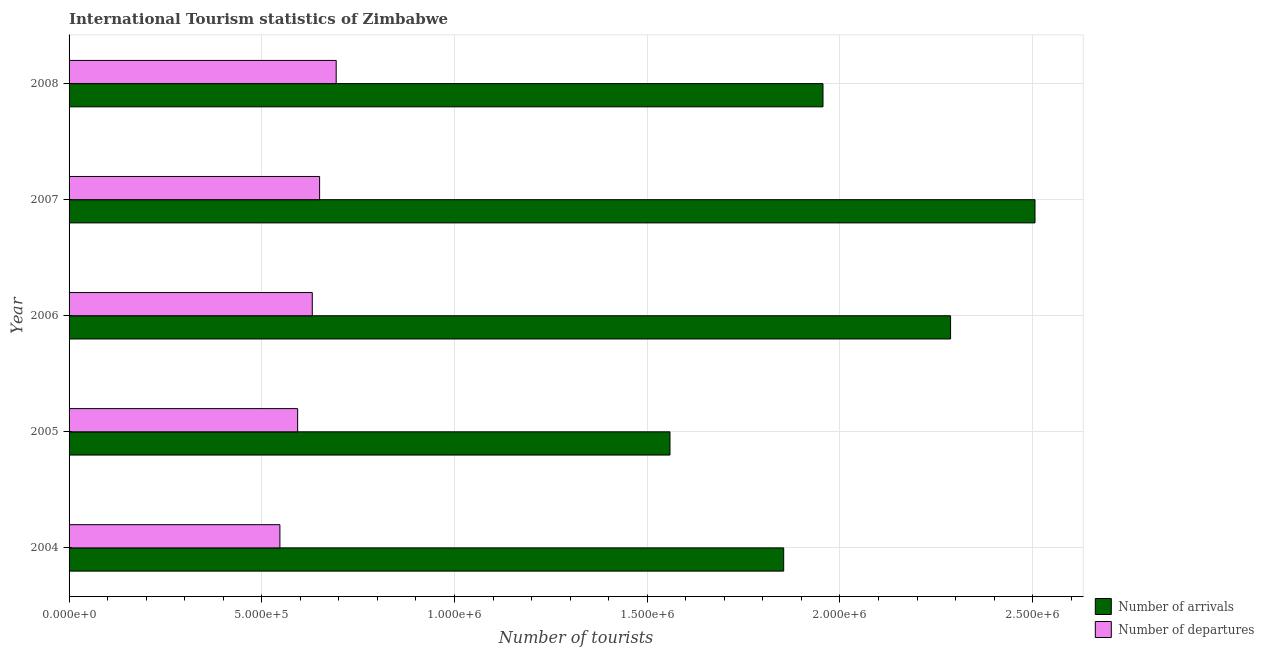Are the number of bars per tick equal to the number of legend labels?
Make the answer very short. Yes. How many bars are there on the 3rd tick from the top?
Provide a short and direct response. 2. How many bars are there on the 1st tick from the bottom?
Offer a terse response. 2. What is the label of the 4th group of bars from the top?
Ensure brevity in your answer.  2005. What is the number of tourist departures in 2005?
Your answer should be very brief. 5.93e+05. Across all years, what is the maximum number of tourist arrivals?
Offer a very short reply. 2.51e+06. Across all years, what is the minimum number of tourist arrivals?
Keep it short and to the point. 1.56e+06. In which year was the number of tourist departures maximum?
Your response must be concise. 2008. What is the total number of tourist departures in the graph?
Make the answer very short. 3.11e+06. What is the difference between the number of tourist arrivals in 2007 and that in 2008?
Provide a succinct answer. 5.50e+05. What is the difference between the number of tourist departures in 2004 and the number of tourist arrivals in 2005?
Make the answer very short. -1.01e+06. What is the average number of tourist arrivals per year?
Provide a short and direct response. 2.03e+06. In the year 2008, what is the difference between the number of tourist departures and number of tourist arrivals?
Provide a succinct answer. -1.26e+06. In how many years, is the number of tourist departures greater than 600000 ?
Provide a short and direct response. 3. What is the ratio of the number of tourist arrivals in 2005 to that in 2006?
Make the answer very short. 0.68. Is the difference between the number of tourist departures in 2007 and 2008 greater than the difference between the number of tourist arrivals in 2007 and 2008?
Give a very brief answer. No. What is the difference between the highest and the second highest number of tourist departures?
Ensure brevity in your answer.  4.30e+04. What is the difference between the highest and the lowest number of tourist arrivals?
Your response must be concise. 9.47e+05. In how many years, is the number of tourist departures greater than the average number of tourist departures taken over all years?
Your answer should be compact. 3. Is the sum of the number of tourist arrivals in 2004 and 2007 greater than the maximum number of tourist departures across all years?
Offer a terse response. Yes. What does the 1st bar from the top in 2005 represents?
Your response must be concise. Number of departures. What does the 2nd bar from the bottom in 2006 represents?
Provide a short and direct response. Number of departures. How many bars are there?
Your response must be concise. 10. What is the difference between two consecutive major ticks on the X-axis?
Your answer should be very brief. 5.00e+05. Are the values on the major ticks of X-axis written in scientific E-notation?
Your answer should be compact. Yes. Where does the legend appear in the graph?
Offer a very short reply. Bottom right. How many legend labels are there?
Keep it short and to the point. 2. How are the legend labels stacked?
Provide a succinct answer. Vertical. What is the title of the graph?
Give a very brief answer. International Tourism statistics of Zimbabwe. What is the label or title of the X-axis?
Your answer should be very brief. Number of tourists. What is the Number of tourists of Number of arrivals in 2004?
Provide a succinct answer. 1.85e+06. What is the Number of tourists of Number of departures in 2004?
Your answer should be compact. 5.47e+05. What is the Number of tourists in Number of arrivals in 2005?
Give a very brief answer. 1.56e+06. What is the Number of tourists in Number of departures in 2005?
Ensure brevity in your answer.  5.93e+05. What is the Number of tourists of Number of arrivals in 2006?
Ensure brevity in your answer.  2.29e+06. What is the Number of tourists of Number of departures in 2006?
Your response must be concise. 6.31e+05. What is the Number of tourists of Number of arrivals in 2007?
Provide a short and direct response. 2.51e+06. What is the Number of tourists in Number of departures in 2007?
Ensure brevity in your answer.  6.50e+05. What is the Number of tourists in Number of arrivals in 2008?
Keep it short and to the point. 1.96e+06. What is the Number of tourists of Number of departures in 2008?
Your answer should be compact. 6.93e+05. Across all years, what is the maximum Number of tourists in Number of arrivals?
Keep it short and to the point. 2.51e+06. Across all years, what is the maximum Number of tourists in Number of departures?
Give a very brief answer. 6.93e+05. Across all years, what is the minimum Number of tourists in Number of arrivals?
Give a very brief answer. 1.56e+06. Across all years, what is the minimum Number of tourists in Number of departures?
Give a very brief answer. 5.47e+05. What is the total Number of tourists in Number of arrivals in the graph?
Your answer should be compact. 1.02e+07. What is the total Number of tourists of Number of departures in the graph?
Offer a terse response. 3.11e+06. What is the difference between the Number of tourists in Number of arrivals in 2004 and that in 2005?
Give a very brief answer. 2.95e+05. What is the difference between the Number of tourists in Number of departures in 2004 and that in 2005?
Keep it short and to the point. -4.60e+04. What is the difference between the Number of tourists of Number of arrivals in 2004 and that in 2006?
Your answer should be very brief. -4.33e+05. What is the difference between the Number of tourists of Number of departures in 2004 and that in 2006?
Make the answer very short. -8.40e+04. What is the difference between the Number of tourists in Number of arrivals in 2004 and that in 2007?
Ensure brevity in your answer.  -6.52e+05. What is the difference between the Number of tourists in Number of departures in 2004 and that in 2007?
Offer a very short reply. -1.03e+05. What is the difference between the Number of tourists of Number of arrivals in 2004 and that in 2008?
Give a very brief answer. -1.02e+05. What is the difference between the Number of tourists of Number of departures in 2004 and that in 2008?
Ensure brevity in your answer.  -1.46e+05. What is the difference between the Number of tourists of Number of arrivals in 2005 and that in 2006?
Offer a terse response. -7.28e+05. What is the difference between the Number of tourists in Number of departures in 2005 and that in 2006?
Your answer should be very brief. -3.80e+04. What is the difference between the Number of tourists of Number of arrivals in 2005 and that in 2007?
Give a very brief answer. -9.47e+05. What is the difference between the Number of tourists of Number of departures in 2005 and that in 2007?
Provide a short and direct response. -5.70e+04. What is the difference between the Number of tourists of Number of arrivals in 2005 and that in 2008?
Provide a succinct answer. -3.97e+05. What is the difference between the Number of tourists in Number of departures in 2005 and that in 2008?
Give a very brief answer. -1.00e+05. What is the difference between the Number of tourists in Number of arrivals in 2006 and that in 2007?
Keep it short and to the point. -2.19e+05. What is the difference between the Number of tourists in Number of departures in 2006 and that in 2007?
Provide a succinct answer. -1.90e+04. What is the difference between the Number of tourists in Number of arrivals in 2006 and that in 2008?
Your response must be concise. 3.31e+05. What is the difference between the Number of tourists of Number of departures in 2006 and that in 2008?
Your answer should be very brief. -6.20e+04. What is the difference between the Number of tourists in Number of departures in 2007 and that in 2008?
Ensure brevity in your answer.  -4.30e+04. What is the difference between the Number of tourists of Number of arrivals in 2004 and the Number of tourists of Number of departures in 2005?
Give a very brief answer. 1.26e+06. What is the difference between the Number of tourists of Number of arrivals in 2004 and the Number of tourists of Number of departures in 2006?
Ensure brevity in your answer.  1.22e+06. What is the difference between the Number of tourists of Number of arrivals in 2004 and the Number of tourists of Number of departures in 2007?
Ensure brevity in your answer.  1.20e+06. What is the difference between the Number of tourists in Number of arrivals in 2004 and the Number of tourists in Number of departures in 2008?
Provide a short and direct response. 1.16e+06. What is the difference between the Number of tourists of Number of arrivals in 2005 and the Number of tourists of Number of departures in 2006?
Provide a short and direct response. 9.28e+05. What is the difference between the Number of tourists of Number of arrivals in 2005 and the Number of tourists of Number of departures in 2007?
Offer a very short reply. 9.09e+05. What is the difference between the Number of tourists in Number of arrivals in 2005 and the Number of tourists in Number of departures in 2008?
Provide a succinct answer. 8.66e+05. What is the difference between the Number of tourists of Number of arrivals in 2006 and the Number of tourists of Number of departures in 2007?
Provide a succinct answer. 1.64e+06. What is the difference between the Number of tourists of Number of arrivals in 2006 and the Number of tourists of Number of departures in 2008?
Your answer should be very brief. 1.59e+06. What is the difference between the Number of tourists in Number of arrivals in 2007 and the Number of tourists in Number of departures in 2008?
Provide a short and direct response. 1.81e+06. What is the average Number of tourists of Number of arrivals per year?
Offer a very short reply. 2.03e+06. What is the average Number of tourists in Number of departures per year?
Your response must be concise. 6.23e+05. In the year 2004, what is the difference between the Number of tourists in Number of arrivals and Number of tourists in Number of departures?
Offer a terse response. 1.31e+06. In the year 2005, what is the difference between the Number of tourists in Number of arrivals and Number of tourists in Number of departures?
Your answer should be compact. 9.66e+05. In the year 2006, what is the difference between the Number of tourists of Number of arrivals and Number of tourists of Number of departures?
Provide a short and direct response. 1.66e+06. In the year 2007, what is the difference between the Number of tourists in Number of arrivals and Number of tourists in Number of departures?
Offer a terse response. 1.86e+06. In the year 2008, what is the difference between the Number of tourists in Number of arrivals and Number of tourists in Number of departures?
Offer a terse response. 1.26e+06. What is the ratio of the Number of tourists of Number of arrivals in 2004 to that in 2005?
Provide a short and direct response. 1.19. What is the ratio of the Number of tourists in Number of departures in 2004 to that in 2005?
Your response must be concise. 0.92. What is the ratio of the Number of tourists in Number of arrivals in 2004 to that in 2006?
Make the answer very short. 0.81. What is the ratio of the Number of tourists of Number of departures in 2004 to that in 2006?
Your response must be concise. 0.87. What is the ratio of the Number of tourists in Number of arrivals in 2004 to that in 2007?
Ensure brevity in your answer.  0.74. What is the ratio of the Number of tourists of Number of departures in 2004 to that in 2007?
Provide a short and direct response. 0.84. What is the ratio of the Number of tourists of Number of arrivals in 2004 to that in 2008?
Your response must be concise. 0.95. What is the ratio of the Number of tourists in Number of departures in 2004 to that in 2008?
Provide a succinct answer. 0.79. What is the ratio of the Number of tourists in Number of arrivals in 2005 to that in 2006?
Provide a short and direct response. 0.68. What is the ratio of the Number of tourists of Number of departures in 2005 to that in 2006?
Your response must be concise. 0.94. What is the ratio of the Number of tourists in Number of arrivals in 2005 to that in 2007?
Your answer should be very brief. 0.62. What is the ratio of the Number of tourists of Number of departures in 2005 to that in 2007?
Ensure brevity in your answer.  0.91. What is the ratio of the Number of tourists in Number of arrivals in 2005 to that in 2008?
Offer a terse response. 0.8. What is the ratio of the Number of tourists of Number of departures in 2005 to that in 2008?
Provide a short and direct response. 0.86. What is the ratio of the Number of tourists of Number of arrivals in 2006 to that in 2007?
Make the answer very short. 0.91. What is the ratio of the Number of tourists in Number of departures in 2006 to that in 2007?
Your answer should be very brief. 0.97. What is the ratio of the Number of tourists of Number of arrivals in 2006 to that in 2008?
Your response must be concise. 1.17. What is the ratio of the Number of tourists of Number of departures in 2006 to that in 2008?
Ensure brevity in your answer.  0.91. What is the ratio of the Number of tourists of Number of arrivals in 2007 to that in 2008?
Your response must be concise. 1.28. What is the ratio of the Number of tourists in Number of departures in 2007 to that in 2008?
Your answer should be very brief. 0.94. What is the difference between the highest and the second highest Number of tourists of Number of arrivals?
Keep it short and to the point. 2.19e+05. What is the difference between the highest and the second highest Number of tourists in Number of departures?
Give a very brief answer. 4.30e+04. What is the difference between the highest and the lowest Number of tourists of Number of arrivals?
Provide a short and direct response. 9.47e+05. What is the difference between the highest and the lowest Number of tourists of Number of departures?
Give a very brief answer. 1.46e+05. 